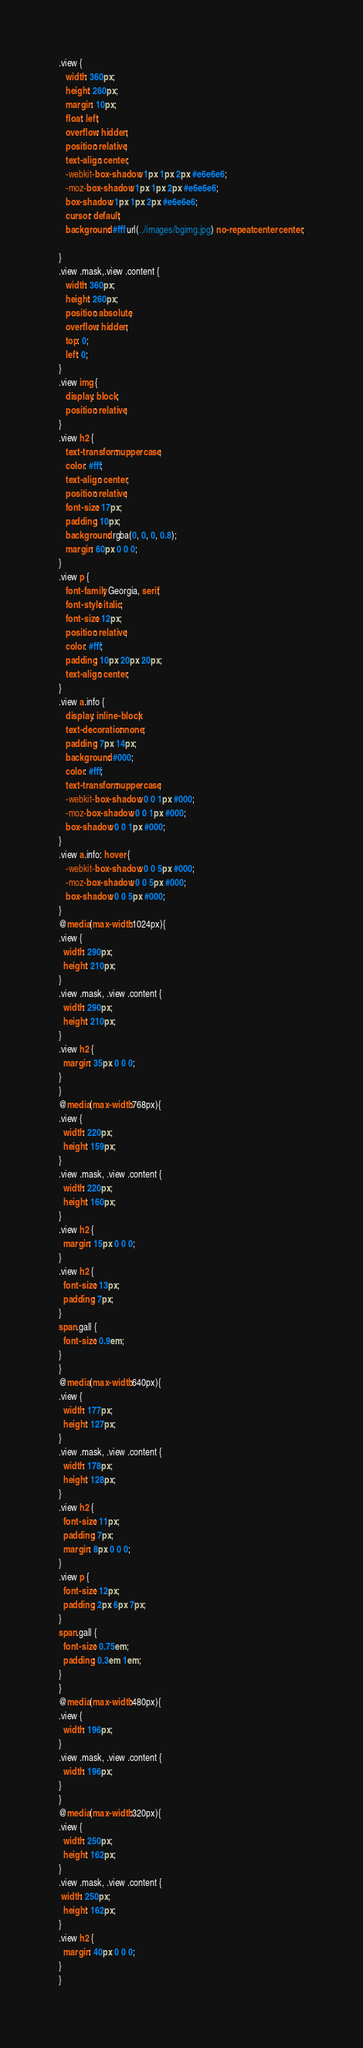Convert code to text. <code><loc_0><loc_0><loc_500><loc_500><_CSS_>.view {
   width: 360px;
   height: 260px;
   margin: 10px;
   float: left;
   overflow: hidden;
   position: relative;
   text-align: center;
   -webkit-box-shadow: 1px 1px 2px #e6e6e6;
   -moz-box-shadow: 1px 1px 2px #e6e6e6;
   box-shadow: 1px 1px 2px #e6e6e6;
   cursor: default;
   background: #fff url(../images/bgimg.jpg) no-repeat center center;
    
}
.view .mask,.view .content {
   width: 360px;
   height: 260px;
   position: absolute;
   overflow: hidden;
   top: 0;
   left: 0;
}
.view img {
   display: block;
   position: relative;
}
.view h2 {
   text-transform: uppercase;
   color: #fff;
   text-align: center;
   position: relative;
   font-size: 17px;
   padding: 10px;
   background: rgba(0, 0, 0, 0.8);
   margin: 60px 0 0 0;
}
.view p {
   font-family: Georgia, serif;
   font-style: italic;
   font-size: 12px;
   position: relative;
   color: #fff;
   padding: 10px 20px 20px;
   text-align: center;
}
.view a.info {
   display: inline-block;
   text-decoration: none;
   padding: 7px 14px;
   background: #000;
   color: #fff;
   text-transform: uppercase;
   -webkit-box-shadow: 0 0 1px #000;
   -moz-box-shadow: 0 0 1px #000;
   box-shadow: 0 0 1px #000;
}
.view a.info: hover {
   -webkit-box-shadow: 0 0 5px #000;
   -moz-box-shadow: 0 0 5px #000;
   box-shadow: 0 0 5px #000;
}
@media(max-width:1024px){
.view {
  width: 290px;
  height: 210px;
}
.view .mask, .view .content {
  width: 290px;
  height: 210px;
}
.view h2 {
  margin: 35px 0 0 0;
}
}
@media(max-width:768px){
.view {
  width: 220px;
  height: 159px;
}
.view .mask, .view .content {
  width: 220px;
  height: 160px;
}
.view h2 {
  margin: 15px 0 0 0;
}
.view h2 {
  font-size: 13px;
  padding: 7px;
}
span.gall {
  font-size: 0.9em;
}
}
@media(max-width:640px){
.view {
  width: 177px;
  height: 127px;
}
.view .mask, .view .content {
  width: 178px;
  height: 128px;
}
.view h2 {
  font-size: 11px;
  padding: 7px;
  margin: 8px 0 0 0;
}
.view p {
  font-size: 12px;
  padding: 2px 6px 7px;
}
span.gall {
  font-size: 0.75em;
  padding: 0.3em 1em;
}
}
@media(max-width:480px){
.view {
  width: 196px;
}	
.view .mask, .view .content {
  width: 196px;
}
}
@media(max-width:320px){
.view {
  width: 250px;
  height: 162px;
}
.view .mask, .view .content {
 width: 250px;
  height: 162px;
}
.view h2 {
  margin: 40px 0 0 0;
}
}</code> 